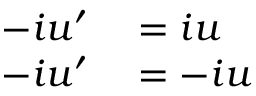Convert formula to latex. <formula><loc_0><loc_0><loc_500><loc_500>\begin{array} { r l } { - i u ^ { \prime } } & = i u } \\ { - i u ^ { \prime } } & = - i u } \end{array}</formula> 